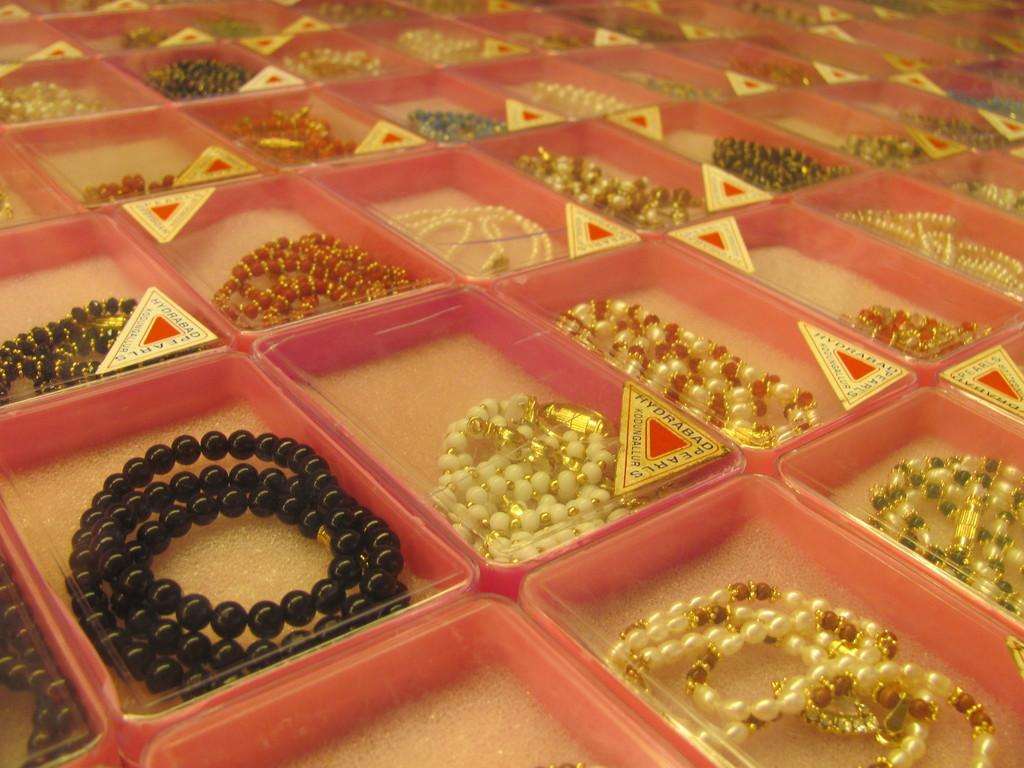What objects are present in the image? There are ornaments in the image. How are the ornaments stored or organized? The ornaments are kept in boxes. What type of knot is used to secure the ornaments in the boxes? There is no mention of knots or any specific method of securing the ornaments in the boxes. How many twigs are present in the image? There is no mention of twigs in the image. 